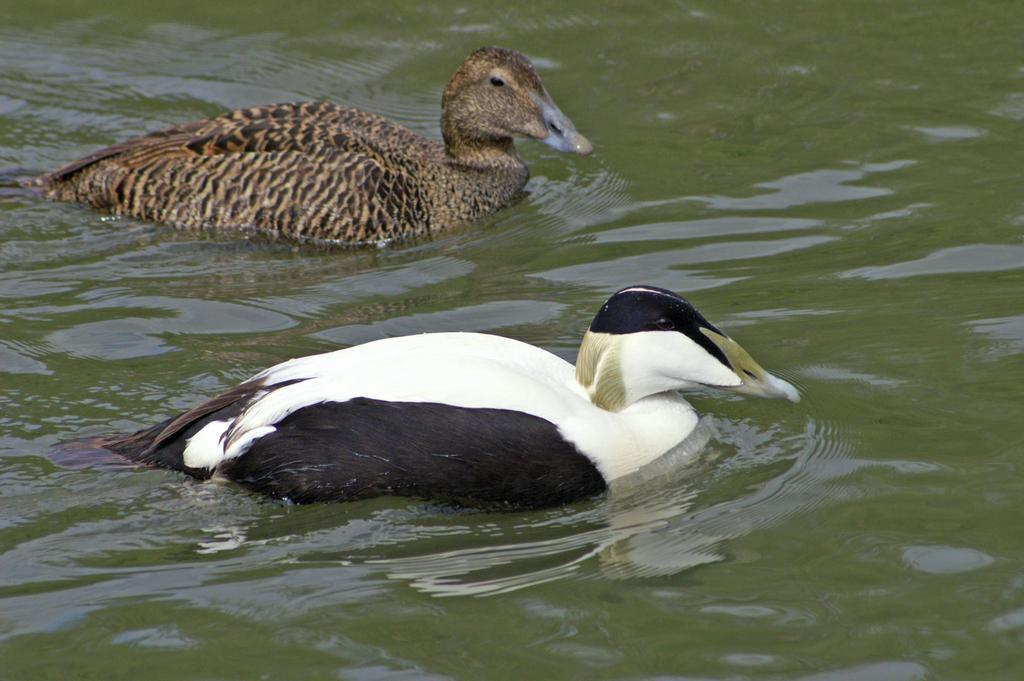What animals can be seen in the water body in the image? There are two ducks in the water body in the image. Can you describe the color of the ducks? One duck is black and white in color, and the other duck is brown in color. What type of ear can be seen on the ducks in the image? Ducks do not have ears like humans, so there are no visible ears on the ducks in the image. 